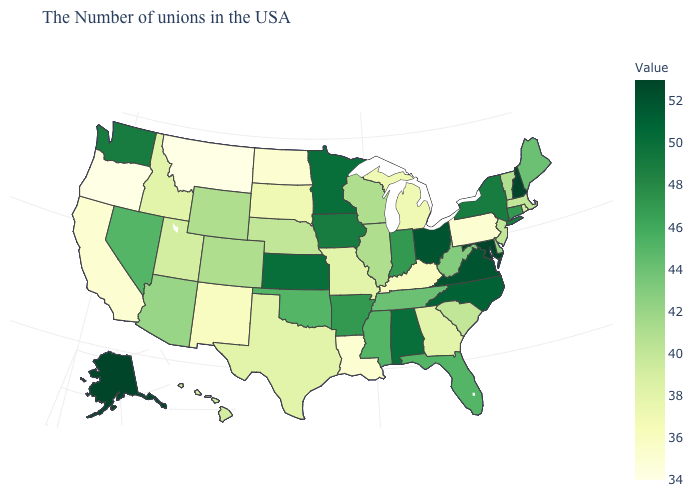Which states hav the highest value in the MidWest?
Answer briefly. Ohio. Among the states that border Ohio , which have the highest value?
Keep it brief. Indiana. Does the map have missing data?
Be succinct. No. Which states have the lowest value in the West?
Write a very short answer. Montana, Oregon. Does Indiana have a higher value than Nebraska?
Keep it brief. Yes. Is the legend a continuous bar?
Concise answer only. Yes. 